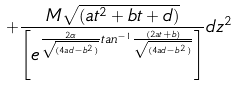Convert formula to latex. <formula><loc_0><loc_0><loc_500><loc_500>+ \frac { M \sqrt { ( a t ^ { 2 } + b t + d ) } } { \left [ e ^ { \frac { 2 \alpha } { \sqrt { ( 4 a d - b ^ { 2 } ) } } t a n ^ { - 1 } \frac { ( 2 a t + b ) } { \sqrt { ( 4 a d - b ^ { 2 } ) } } } \right ] } d z ^ { 2 }</formula> 